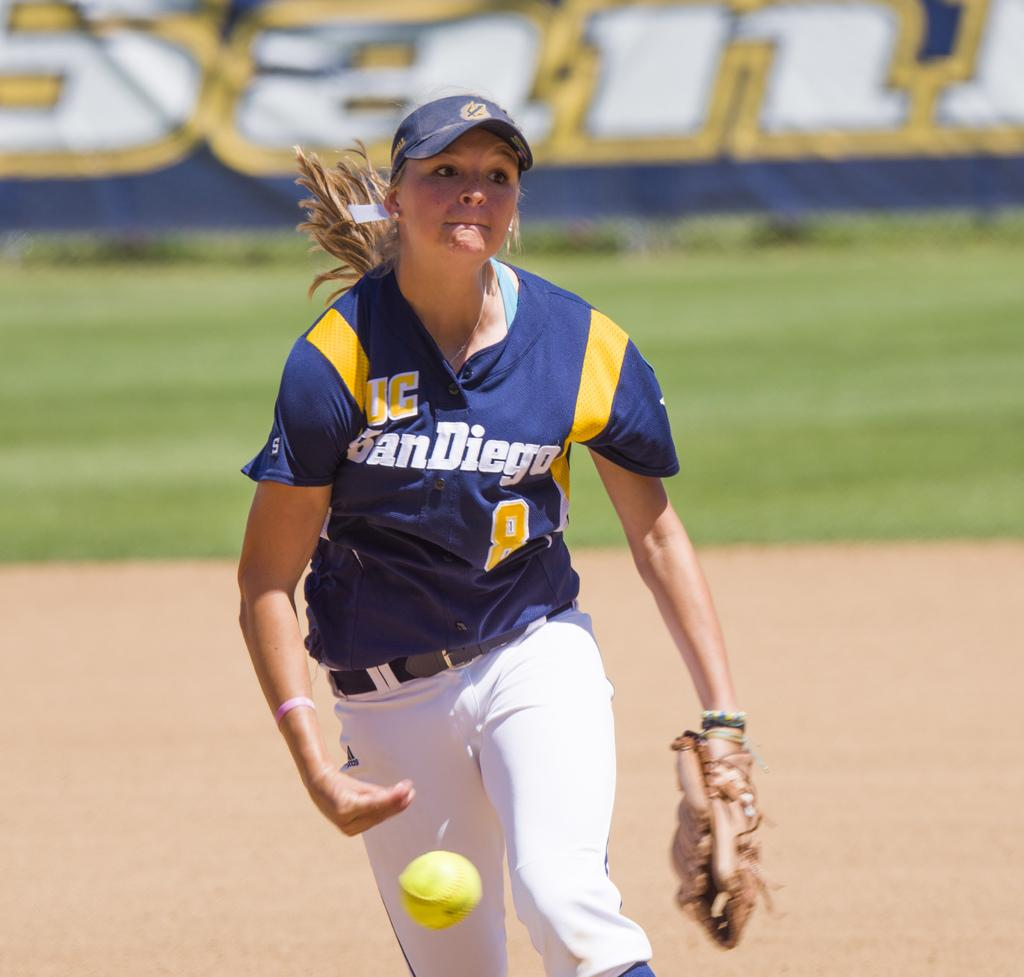<image>
Offer a succinct explanation of the picture presented. a san diego softball player throwing a yellow ball 